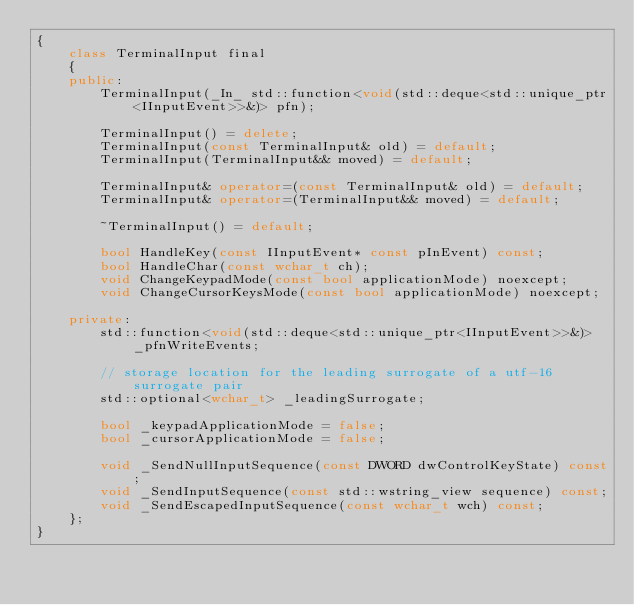Convert code to text. <code><loc_0><loc_0><loc_500><loc_500><_C++_>{
    class TerminalInput final
    {
    public:
        TerminalInput(_In_ std::function<void(std::deque<std::unique_ptr<IInputEvent>>&)> pfn);

        TerminalInput() = delete;
        TerminalInput(const TerminalInput& old) = default;
        TerminalInput(TerminalInput&& moved) = default;

        TerminalInput& operator=(const TerminalInput& old) = default;
        TerminalInput& operator=(TerminalInput&& moved) = default;

        ~TerminalInput() = default;

        bool HandleKey(const IInputEvent* const pInEvent) const;
        bool HandleChar(const wchar_t ch);
        void ChangeKeypadMode(const bool applicationMode) noexcept;
        void ChangeCursorKeysMode(const bool applicationMode) noexcept;

    private:
        std::function<void(std::deque<std::unique_ptr<IInputEvent>>&)> _pfnWriteEvents;

        // storage location for the leading surrogate of a utf-16 surrogate pair
        std::optional<wchar_t> _leadingSurrogate;

        bool _keypadApplicationMode = false;
        bool _cursorApplicationMode = false;

        void _SendNullInputSequence(const DWORD dwControlKeyState) const;
        void _SendInputSequence(const std::wstring_view sequence) const;
        void _SendEscapedInputSequence(const wchar_t wch) const;
    };
}
</code> 